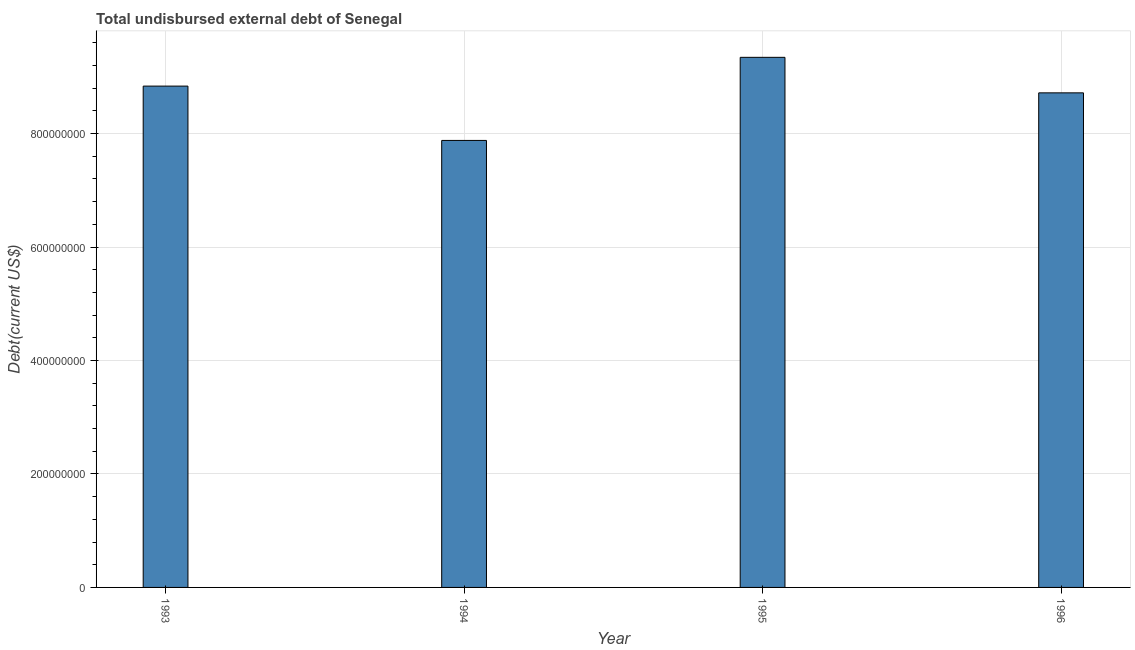Does the graph contain any zero values?
Give a very brief answer. No. What is the title of the graph?
Keep it short and to the point. Total undisbursed external debt of Senegal. What is the label or title of the X-axis?
Your answer should be very brief. Year. What is the label or title of the Y-axis?
Offer a very short reply. Debt(current US$). What is the total debt in 1993?
Make the answer very short. 8.84e+08. Across all years, what is the maximum total debt?
Give a very brief answer. 9.34e+08. Across all years, what is the minimum total debt?
Offer a terse response. 7.88e+08. In which year was the total debt maximum?
Provide a short and direct response. 1995. What is the sum of the total debt?
Provide a succinct answer. 3.48e+09. What is the difference between the total debt in 1993 and 1995?
Offer a terse response. -5.07e+07. What is the average total debt per year?
Ensure brevity in your answer.  8.69e+08. What is the median total debt?
Give a very brief answer. 8.78e+08. In how many years, is the total debt greater than 400000000 US$?
Provide a succinct answer. 4. Is the total debt in 1993 less than that in 1996?
Offer a very short reply. No. What is the difference between the highest and the second highest total debt?
Give a very brief answer. 5.07e+07. Is the sum of the total debt in 1994 and 1996 greater than the maximum total debt across all years?
Your answer should be very brief. Yes. What is the difference between the highest and the lowest total debt?
Offer a very short reply. 1.46e+08. In how many years, is the total debt greater than the average total debt taken over all years?
Give a very brief answer. 3. How many bars are there?
Give a very brief answer. 4. How many years are there in the graph?
Your answer should be compact. 4. What is the difference between two consecutive major ticks on the Y-axis?
Keep it short and to the point. 2.00e+08. What is the Debt(current US$) of 1993?
Offer a terse response. 8.84e+08. What is the Debt(current US$) in 1994?
Give a very brief answer. 7.88e+08. What is the Debt(current US$) of 1995?
Your answer should be very brief. 9.34e+08. What is the Debt(current US$) in 1996?
Keep it short and to the point. 8.72e+08. What is the difference between the Debt(current US$) in 1993 and 1994?
Your response must be concise. 9.58e+07. What is the difference between the Debt(current US$) in 1993 and 1995?
Give a very brief answer. -5.07e+07. What is the difference between the Debt(current US$) in 1993 and 1996?
Ensure brevity in your answer.  1.19e+07. What is the difference between the Debt(current US$) in 1994 and 1995?
Give a very brief answer. -1.46e+08. What is the difference between the Debt(current US$) in 1994 and 1996?
Make the answer very short. -8.39e+07. What is the difference between the Debt(current US$) in 1995 and 1996?
Your answer should be very brief. 6.26e+07. What is the ratio of the Debt(current US$) in 1993 to that in 1994?
Keep it short and to the point. 1.12. What is the ratio of the Debt(current US$) in 1993 to that in 1995?
Offer a very short reply. 0.95. What is the ratio of the Debt(current US$) in 1994 to that in 1995?
Provide a short and direct response. 0.84. What is the ratio of the Debt(current US$) in 1994 to that in 1996?
Ensure brevity in your answer.  0.9. What is the ratio of the Debt(current US$) in 1995 to that in 1996?
Ensure brevity in your answer.  1.07. 